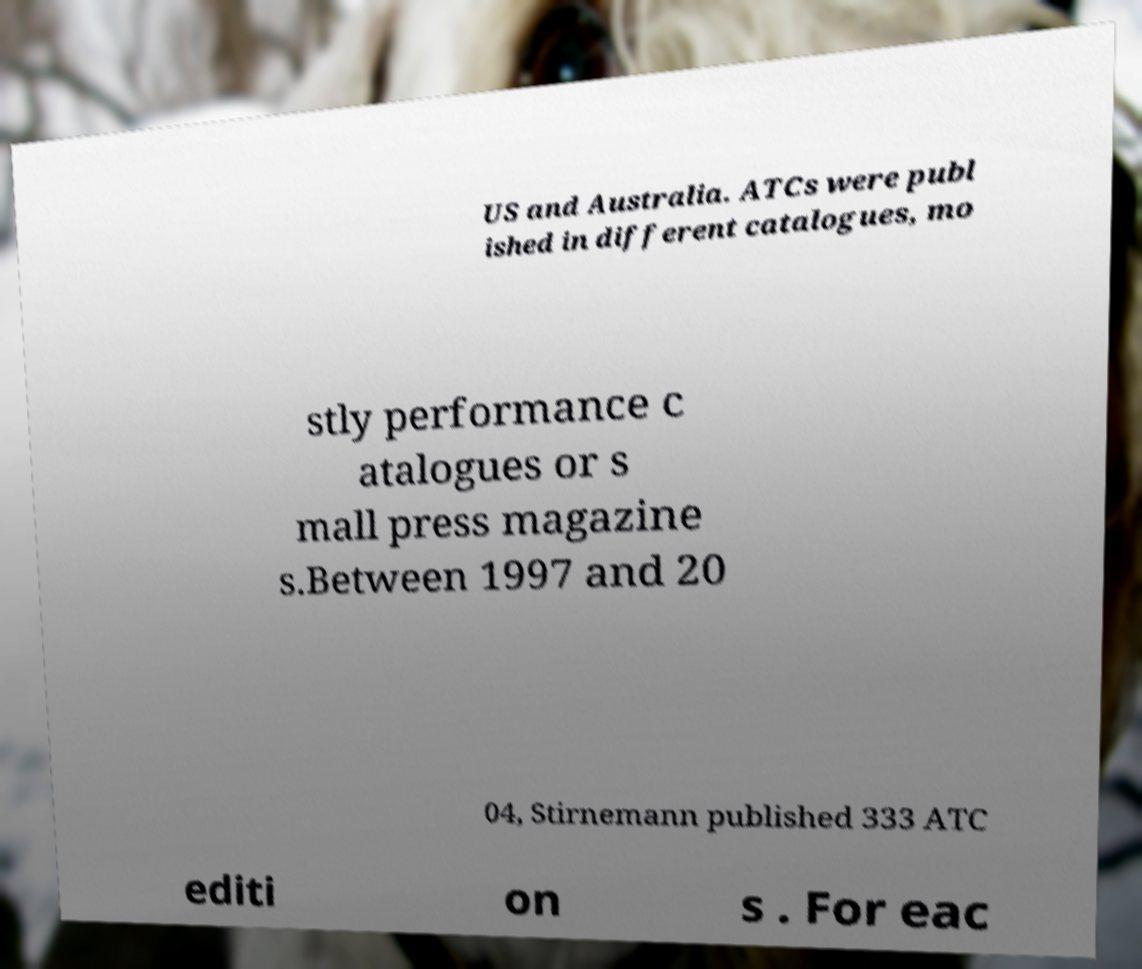There's text embedded in this image that I need extracted. Can you transcribe it verbatim? US and Australia. ATCs were publ ished in different catalogues, mo stly performance c atalogues or s mall press magazine s.Between 1997 and 20 04, Stirnemann published 333 ATC editi on s . For eac 